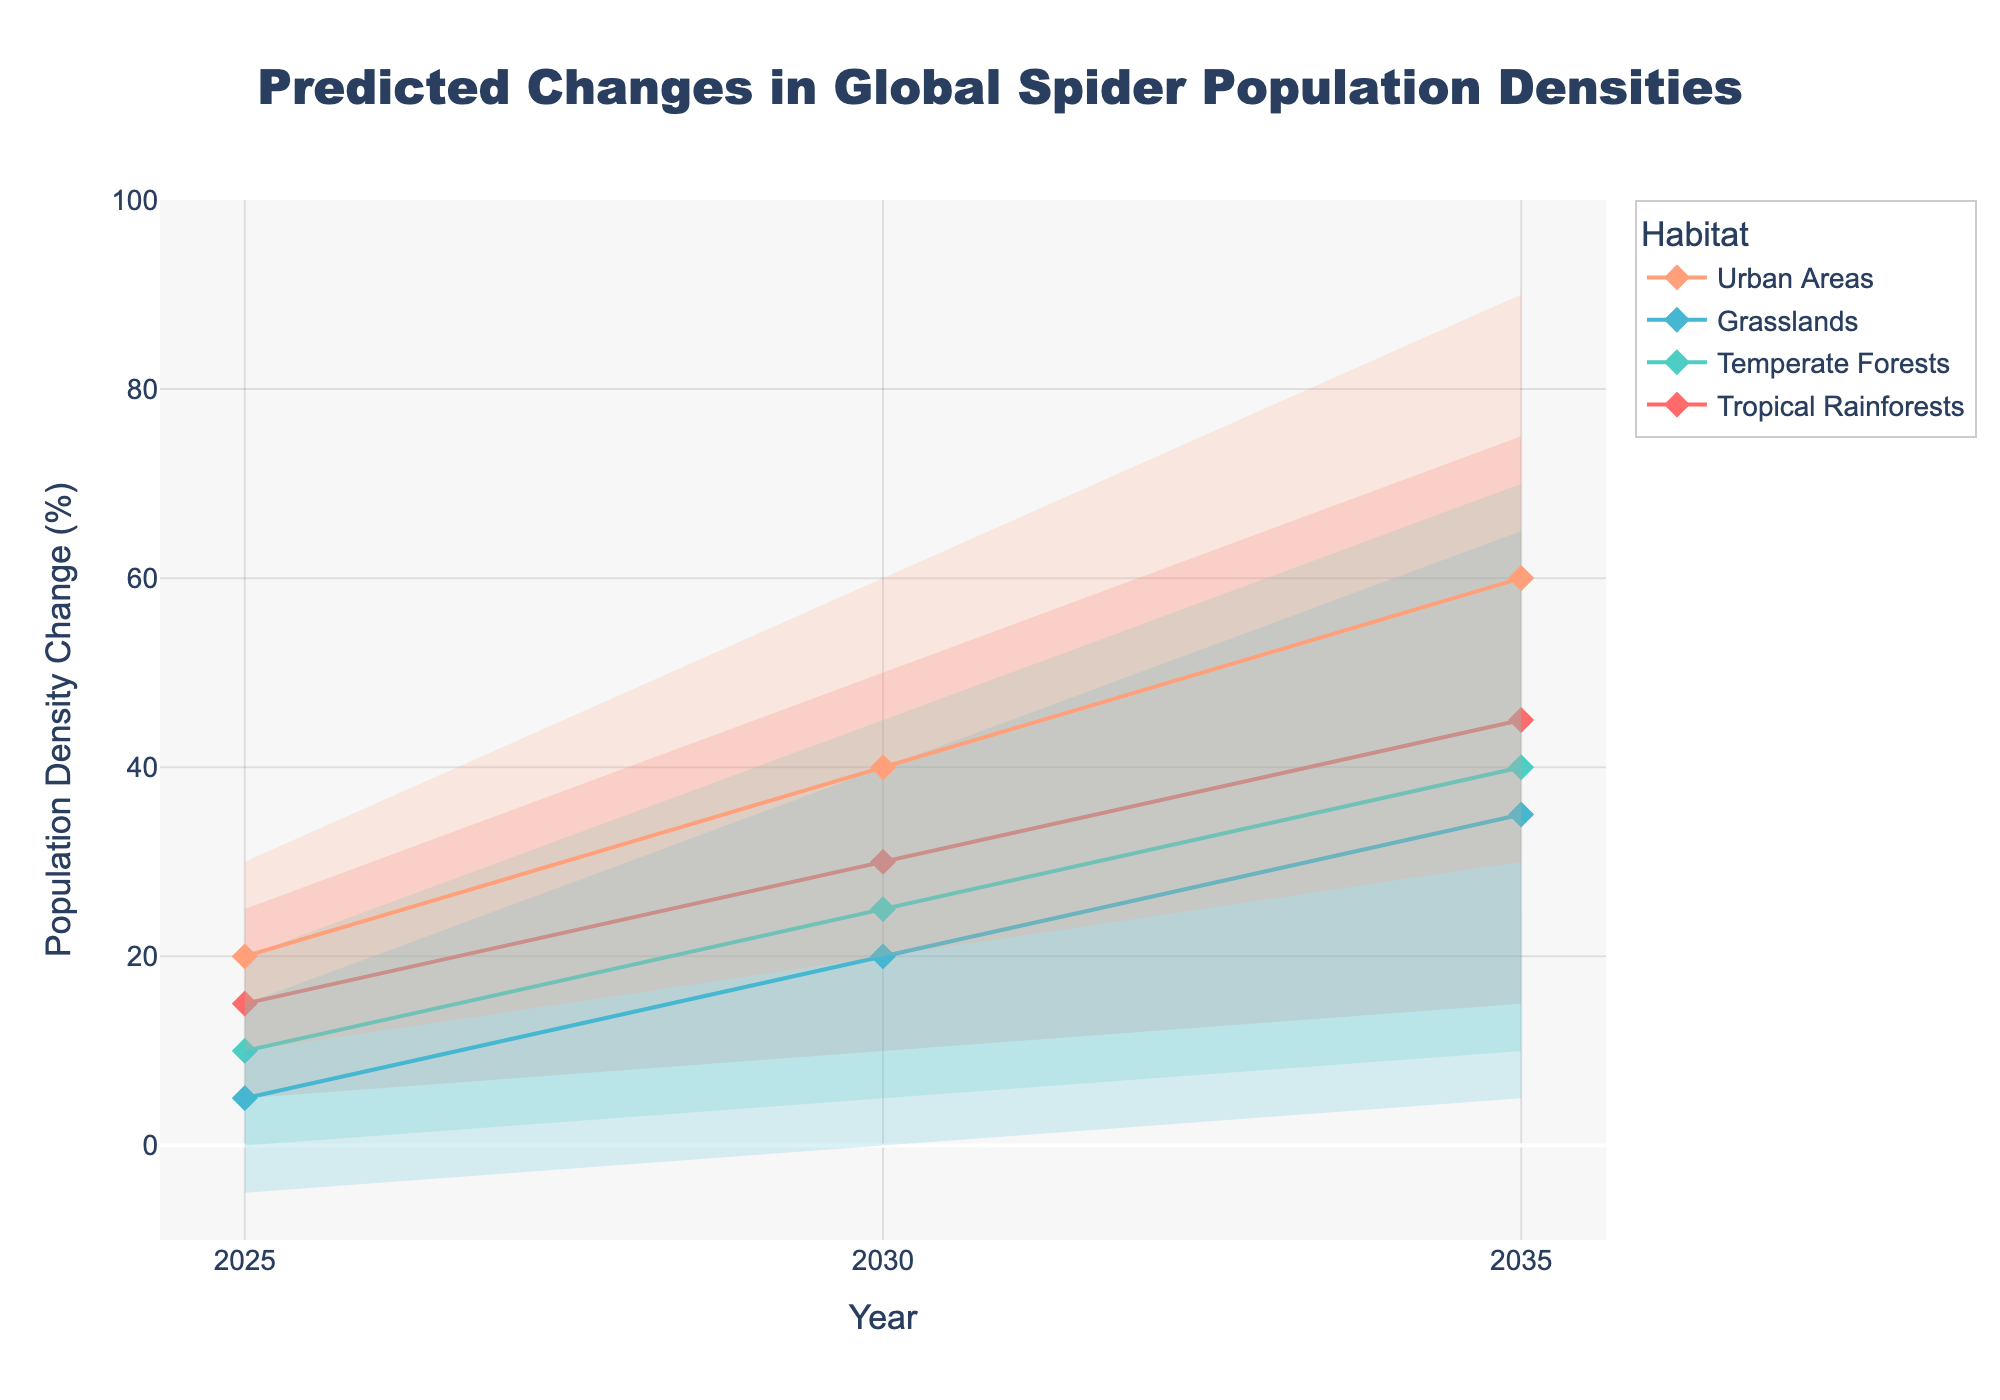How many habitats are shown in the chart? The chart shows the changes in global spider population densities across different habitats. By counting the distinct colors and labels for the habitats in the legend, we see that there are four habitats.
Answer: Four What is the predicted median population density change in Tropical Rainforests by 2030? Locate the median value for Tropical Rainforests (indicated by the line with markers) at the year 2030 on the x-axis. The y-value for this point is 30%.
Answer: 30% By how much do the lower middle values for Grasslands increase from 2025 to 2035? Find the lower middle values for Grasslands in 2025 and 2035. Subtract the lower middle value in 2025 (0%) from that in 2035 (20%).
Answer: 20% Which habitat shows the highest upper bound prediction in 2035, and what is the value? Check the upper bounds for all habitats in the year 2035. The highest upper bound is in Urban Areas with a value of 90%.
Answer: Urban Areas, 90% What is the median difference in population density change between Urban Areas and Grasslands in 2025? Find the median values for Urban Areas and Grasslands in 2025. The value for Urban Areas is 20% and for Grasslands is 5%. The difference is 20% - 5% = 15%.
Answer: 15% In which year is the median population density change in Temperate Forests predicted to be 40%? Check the median values for Temperate Forests across the years and find the year where the value is 40%. It is 2035.
Answer: 2035 What is the range of predicted changes (from lower bound to upper bound) for Urban Areas in 2030? For Urban Areas in 2030, the lower bound is 20% and the upper bound is 60%. Calculate the range as 60% - 20% = 40%.
Answer: 40% Which habitat has the least predicted median change in population density in 2025? Compare the median values for all habitats in 2025 and identify the smallest value. Grasslands have the lowest median change at 5%.
Answer: Grasslands 